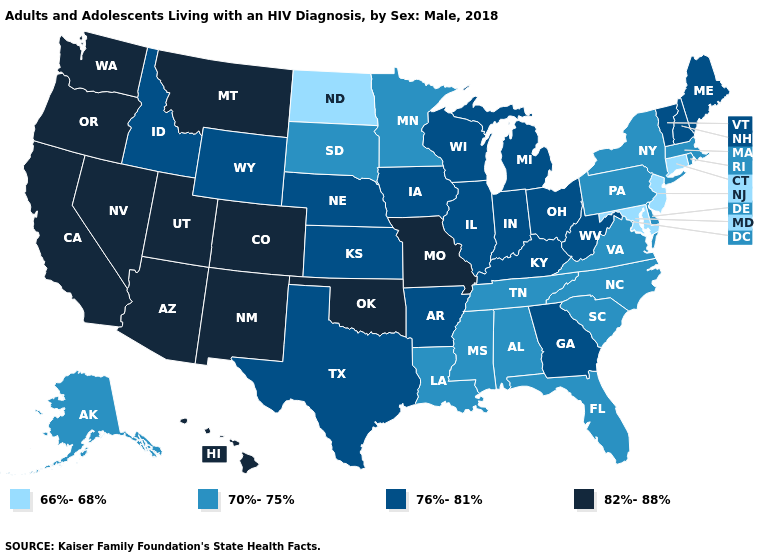Among the states that border North Carolina , does Georgia have the lowest value?
Give a very brief answer. No. Does Connecticut have the lowest value in the USA?
Keep it brief. Yes. Which states have the lowest value in the South?
Concise answer only. Maryland. Name the states that have a value in the range 70%-75%?
Be succinct. Alabama, Alaska, Delaware, Florida, Louisiana, Massachusetts, Minnesota, Mississippi, New York, North Carolina, Pennsylvania, Rhode Island, South Carolina, South Dakota, Tennessee, Virginia. Which states have the highest value in the USA?
Short answer required. Arizona, California, Colorado, Hawaii, Missouri, Montana, Nevada, New Mexico, Oklahoma, Oregon, Utah, Washington. What is the lowest value in the West?
Be succinct. 70%-75%. Name the states that have a value in the range 76%-81%?
Quick response, please. Arkansas, Georgia, Idaho, Illinois, Indiana, Iowa, Kansas, Kentucky, Maine, Michigan, Nebraska, New Hampshire, Ohio, Texas, Vermont, West Virginia, Wisconsin, Wyoming. Name the states that have a value in the range 76%-81%?
Concise answer only. Arkansas, Georgia, Idaho, Illinois, Indiana, Iowa, Kansas, Kentucky, Maine, Michigan, Nebraska, New Hampshire, Ohio, Texas, Vermont, West Virginia, Wisconsin, Wyoming. Which states have the lowest value in the USA?
Keep it brief. Connecticut, Maryland, New Jersey, North Dakota. What is the lowest value in the South?
Keep it brief. 66%-68%. What is the value of Mississippi?
Be succinct. 70%-75%. What is the lowest value in the USA?
Write a very short answer. 66%-68%. How many symbols are there in the legend?
Concise answer only. 4. Name the states that have a value in the range 82%-88%?
Give a very brief answer. Arizona, California, Colorado, Hawaii, Missouri, Montana, Nevada, New Mexico, Oklahoma, Oregon, Utah, Washington. 